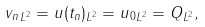Convert formula to latex. <formula><loc_0><loc_0><loc_500><loc_500>\| v _ { n } \| _ { L ^ { 2 } } = \| u ( t _ { n } ) \| _ { L ^ { 2 } } = \| u _ { 0 } \| _ { L ^ { 2 } } = \| Q \| _ { L ^ { 2 } } ,</formula> 